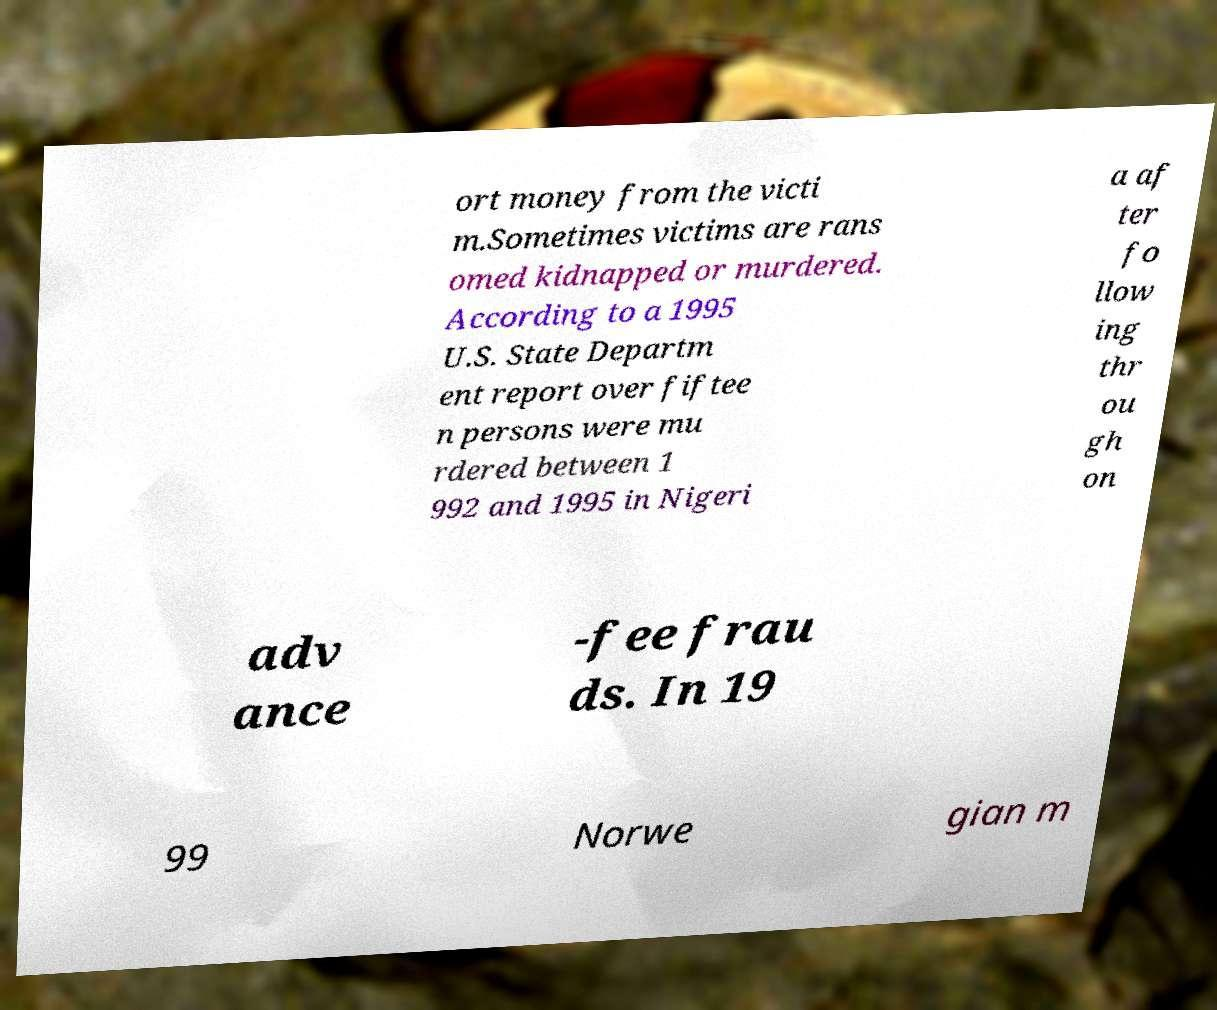Can you accurately transcribe the text from the provided image for me? ort money from the victi m.Sometimes victims are rans omed kidnapped or murdered. According to a 1995 U.S. State Departm ent report over fiftee n persons were mu rdered between 1 992 and 1995 in Nigeri a af ter fo llow ing thr ou gh on adv ance -fee frau ds. In 19 99 Norwe gian m 